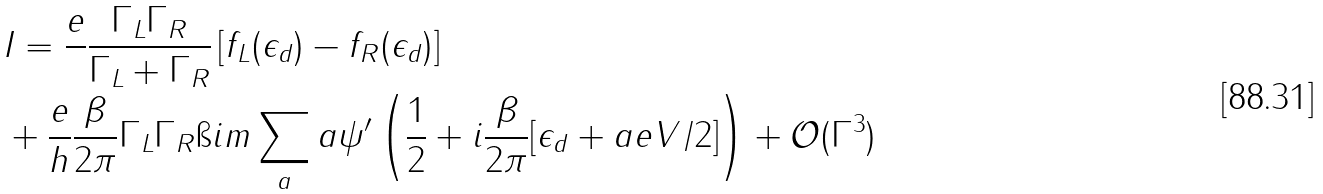<formula> <loc_0><loc_0><loc_500><loc_500>& I = \frac { e } { } \frac { \Gamma _ { L } \Gamma _ { R } } { \Gamma _ { L } + \Gamma _ { R } } \left [ f _ { L } ( \epsilon _ { d } ) - f _ { R } ( \epsilon _ { d } ) \right ] \\ & + \frac { e } { h } \frac { \beta } { 2 \pi } \Gamma _ { L } \Gamma _ { R } \i i m \sum _ { a } a \psi ^ { \prime } \left ( \frac { 1 } { 2 } + i \frac { \beta } { 2 \pi } [ \epsilon _ { d } + a e V / 2 ] \right ) + \mathcal { O } ( \Gamma ^ { 3 } )</formula> 